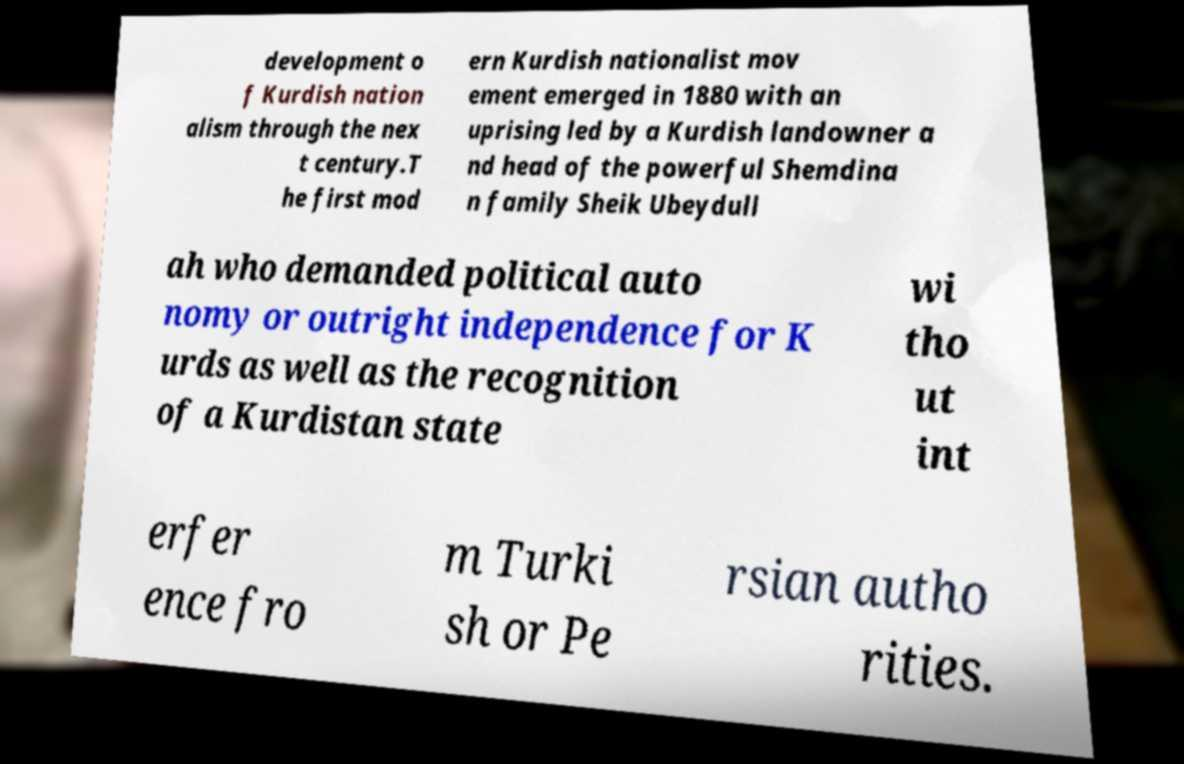There's text embedded in this image that I need extracted. Can you transcribe it verbatim? development o f Kurdish nation alism through the nex t century.T he first mod ern Kurdish nationalist mov ement emerged in 1880 with an uprising led by a Kurdish landowner a nd head of the powerful Shemdina n family Sheik Ubeydull ah who demanded political auto nomy or outright independence for K urds as well as the recognition of a Kurdistan state wi tho ut int erfer ence fro m Turki sh or Pe rsian autho rities. 